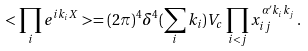Convert formula to latex. <formula><loc_0><loc_0><loc_500><loc_500>< \prod _ { i } e ^ { i k _ { i } X } > = ( 2 \pi ) ^ { 4 } \delta ^ { 4 } ( \sum _ { i } k _ { i } ) V _ { c } \prod _ { i < j } x ^ { \alpha ^ { \prime } k _ { i } k _ { j } } _ { i j } \, .</formula> 